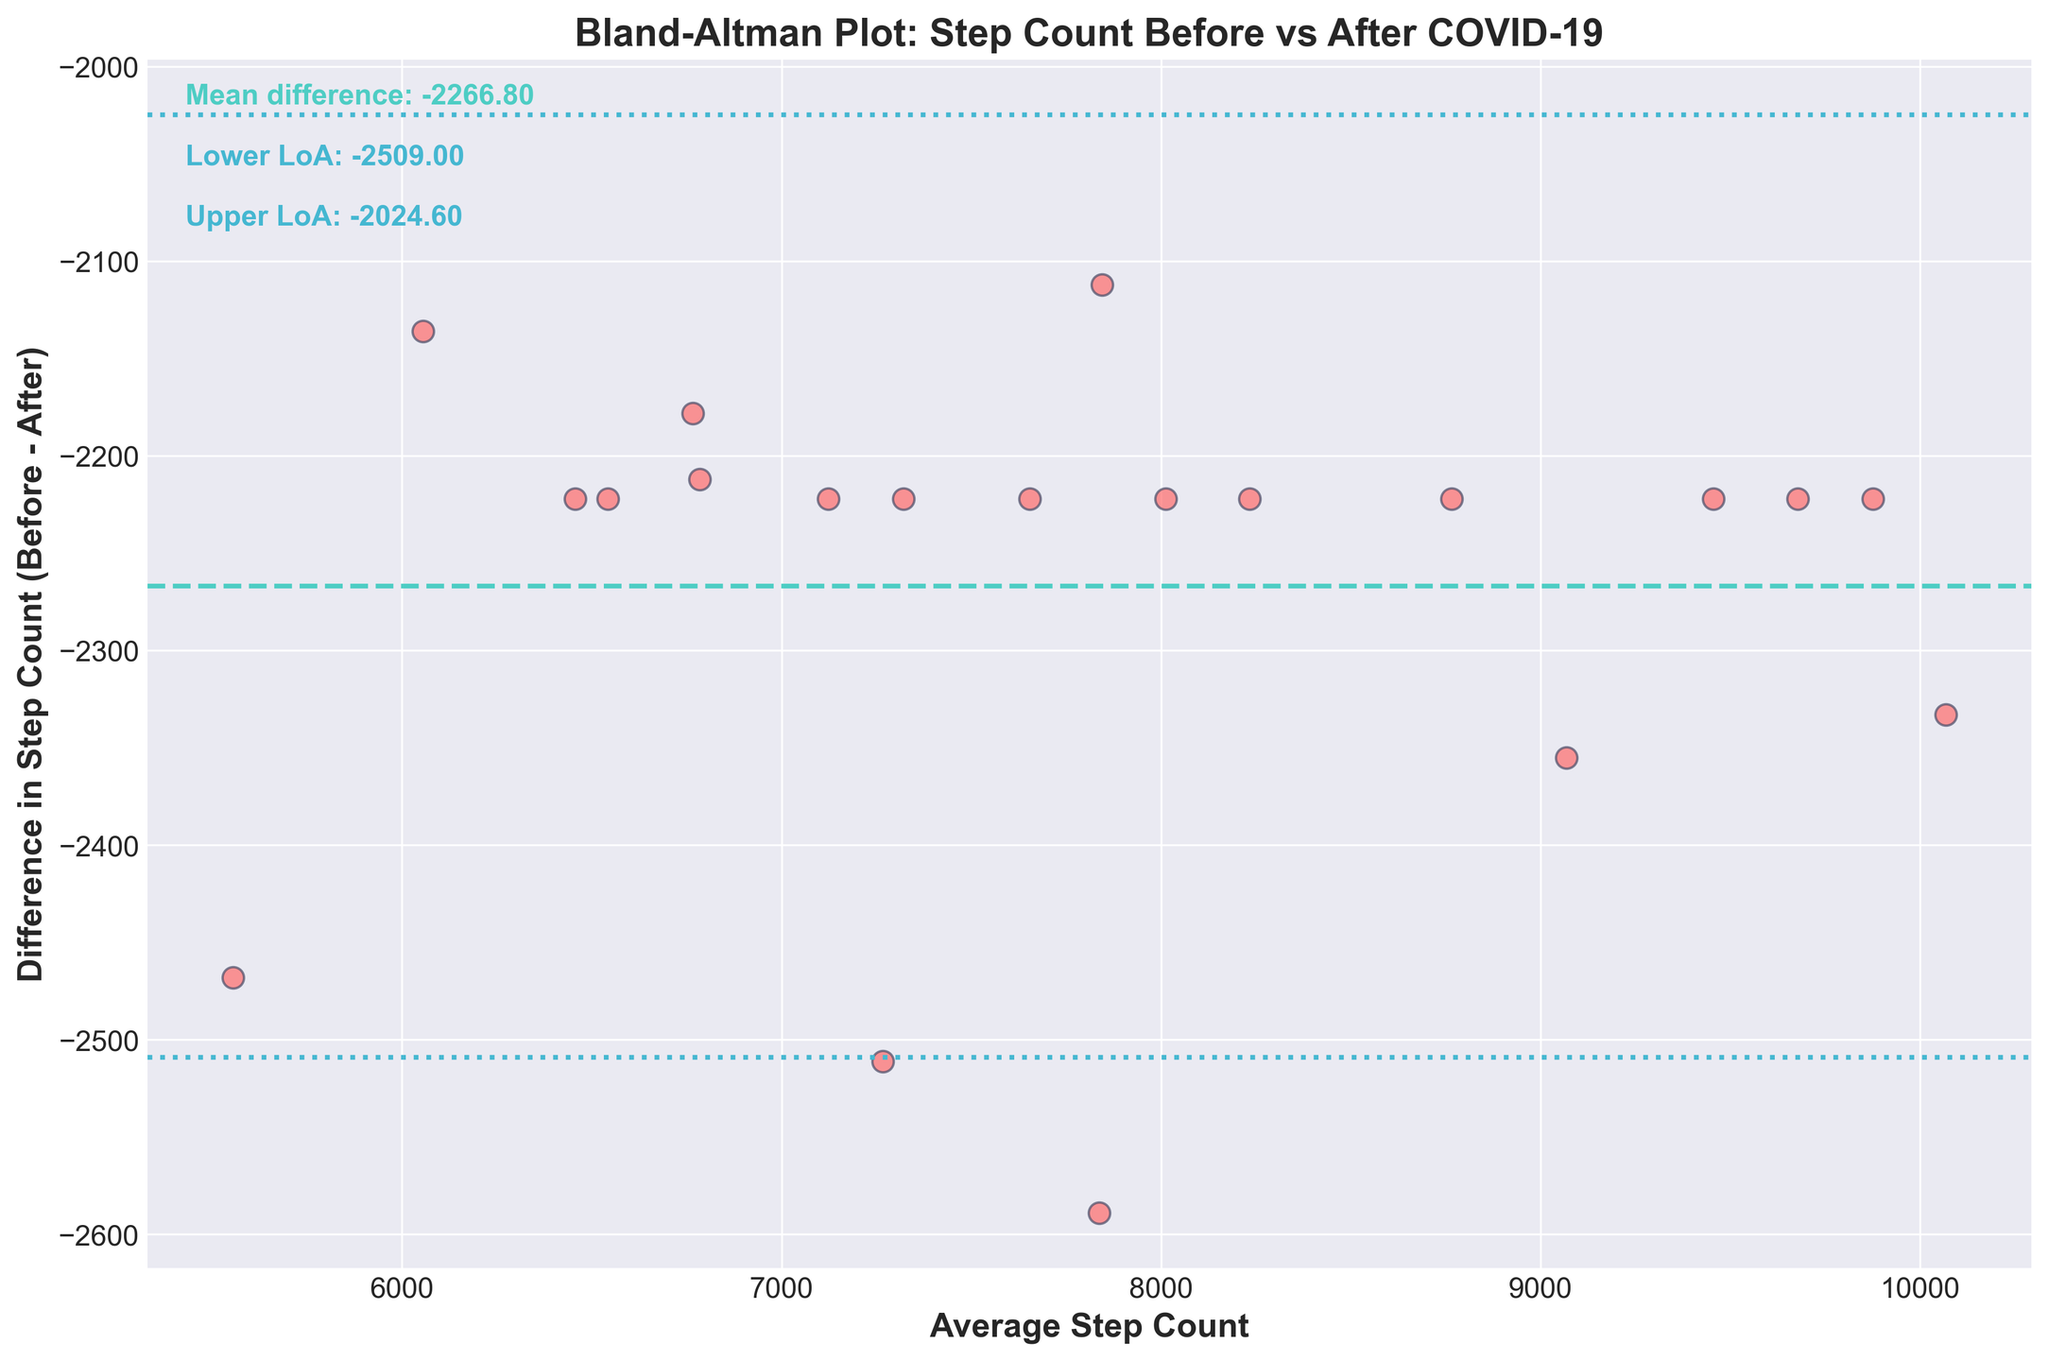What is the title of the plot? The title of the plot is located at the top, centered above the chart. It reads "Bland-Altman Plot: Step Count Before vs After COVID-19."
Answer: Bland-Altman Plot: Step Count Before vs After COVID-19 What do the x and y axes represent? The x-axis represents the "Average Step Count," while the y-axis represents the "Difference in Step Count (Before - After)." These labels are found beneath the x-axis and beside the y-axis.
Answer: Average Step Count, Difference in Step Count (Before - After) What is the color of the data points on the plot? The data points on the plot are displayed as scattered points in a shade of pink with edge colors in blue. These visual elements help distinguish the points clearly on the plot.
Answer: Pink with blue edges What is the mean difference of the step counts before and after COVID-19? The mean difference is a horizontal line shown in the plot. The value is also noted in the text box within the plot. It reads: "Mean difference: -2225.6."
Answer: -2225.6 What are the limits of agreement in the plot? The limits of agreement are indicated by two dashed lines above and below the mean difference line. The values are given in the annotations: "Lower LoA: -2443.36" and "Upper LoA: -2007.84."
Answer: -2443.36, -2007.84 How many data points are shown in the plot? The plot contains one data point for each pair of step counts before and after COVID-19. Counting the dots reveals there are 20 data points.
Answer: 20 Is there a visible trend in the difference of step counts when the average step counts increase? The scatter of data points doesn't reveal a clear trend, as the differences remain fairly consistent around the mean difference line regardless of the average step count on the x-axis.
Answer: No clear trend Are there any data points that lie outside the limits of agreement? Observing the scatter plot and the two limits of agreement lines, no data points are positioned outside these lines. They all lie within the given range.
Answer: No How consistent are the differences in step counts before and after COVID-19 across varying averages? The data points show a fairly consistent range for differences in step counts with little variation. They stay around the mean difference line, and the difference values predominantly cluster around -2222.
Answer: Fairly consistent What do the limits of agreement tell us about the variability in step counts? The limits of agreement (Upper LoA and Lower LoA) give a range within which most differences fall, indicating the variability in step counts before and after COVID-19. Here, it shows most differences fall between approximately -2443.36 and -2007.84.
Answer: Range of variability: -2443.36 to -2007.84 